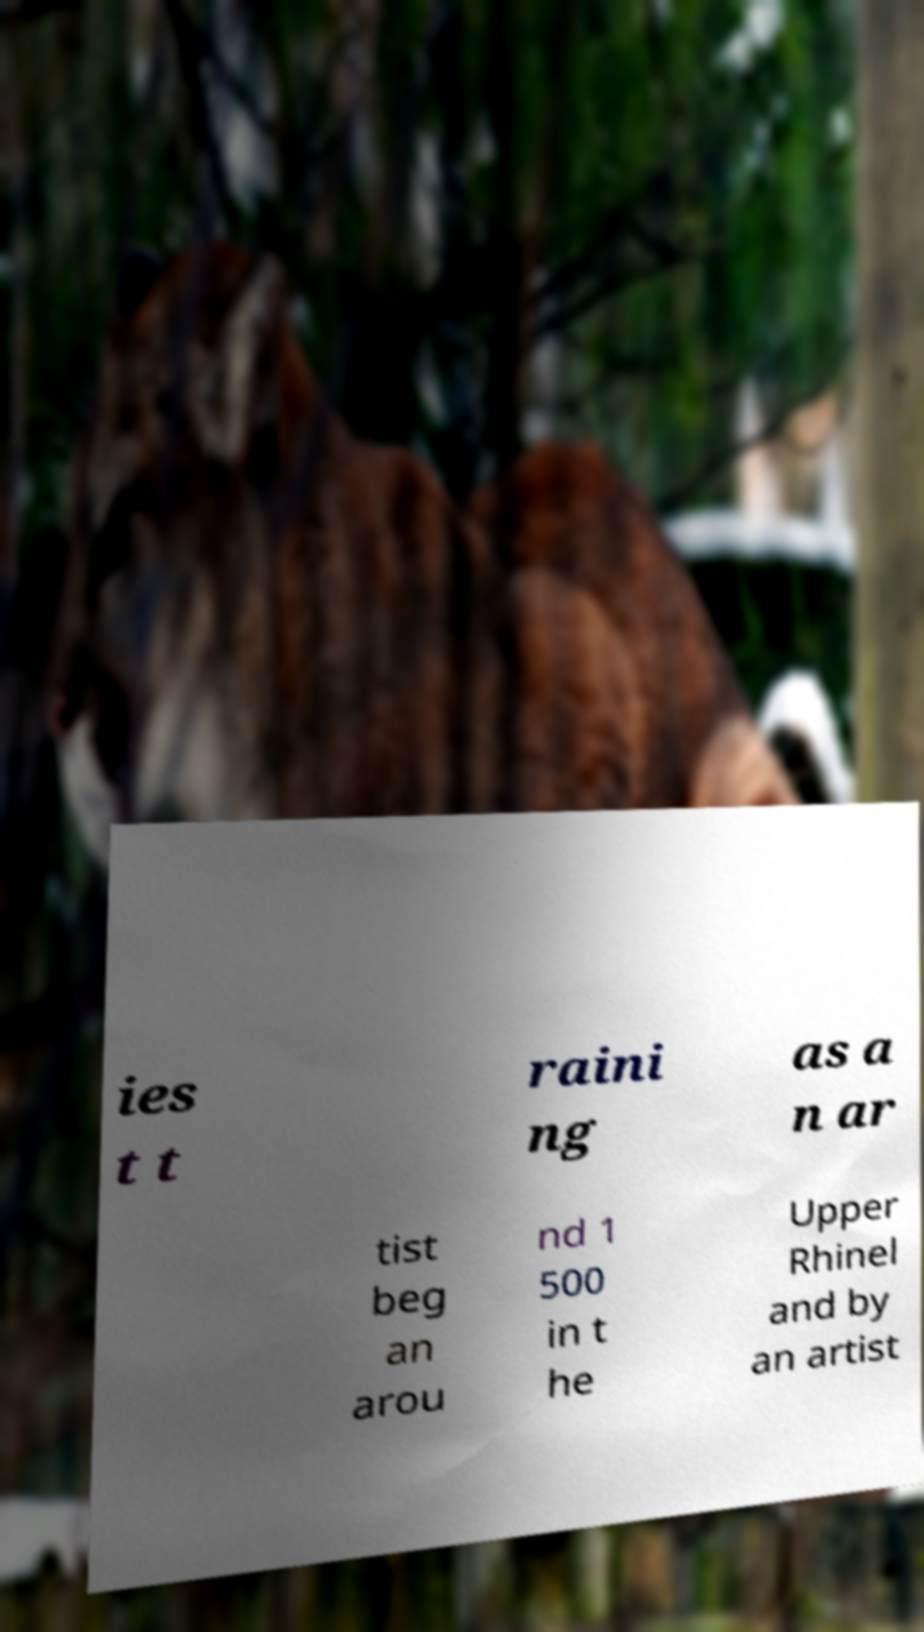For documentation purposes, I need the text within this image transcribed. Could you provide that? ies t t raini ng as a n ar tist beg an arou nd 1 500 in t he Upper Rhinel and by an artist 